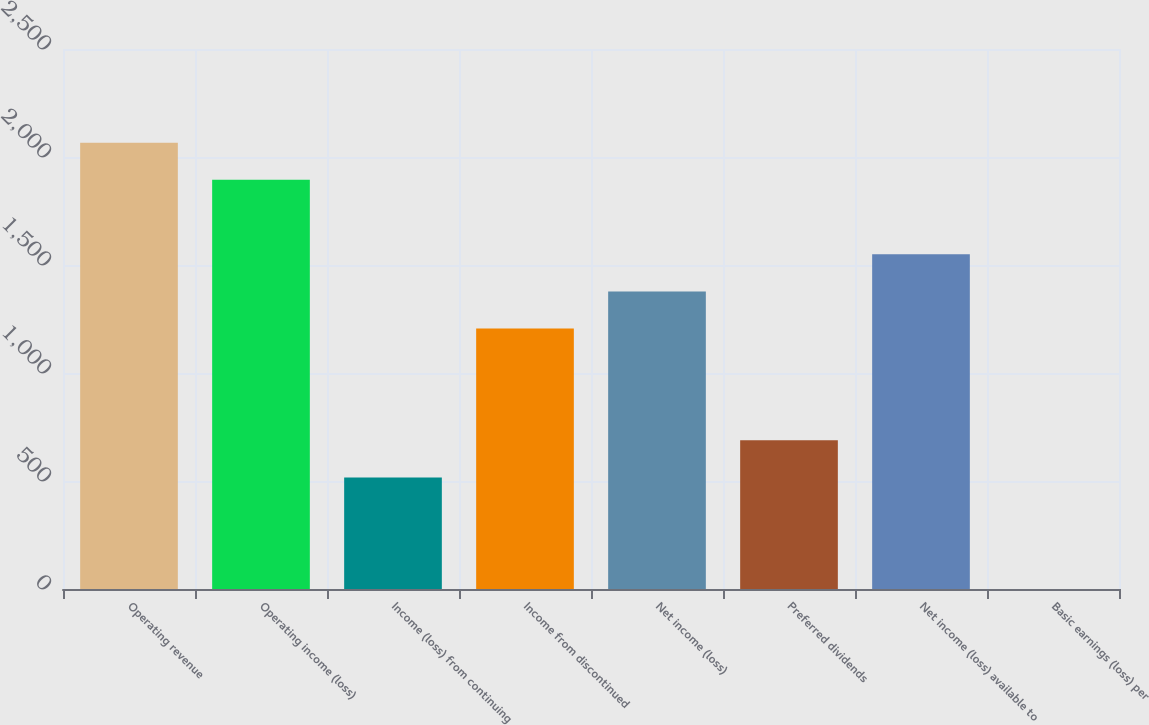Convert chart. <chart><loc_0><loc_0><loc_500><loc_500><bar_chart><fcel>Operating revenue<fcel>Operating income (loss)<fcel>Income (loss) from continuing<fcel>Income from discontinued<fcel>Net income (loss)<fcel>Preferred dividends<fcel>Net income (loss) available to<fcel>Basic earnings (loss) per<nl><fcel>2066.35<fcel>1894.16<fcel>516.7<fcel>1205.44<fcel>1377.62<fcel>688.88<fcel>1549.8<fcel>0.15<nl></chart> 